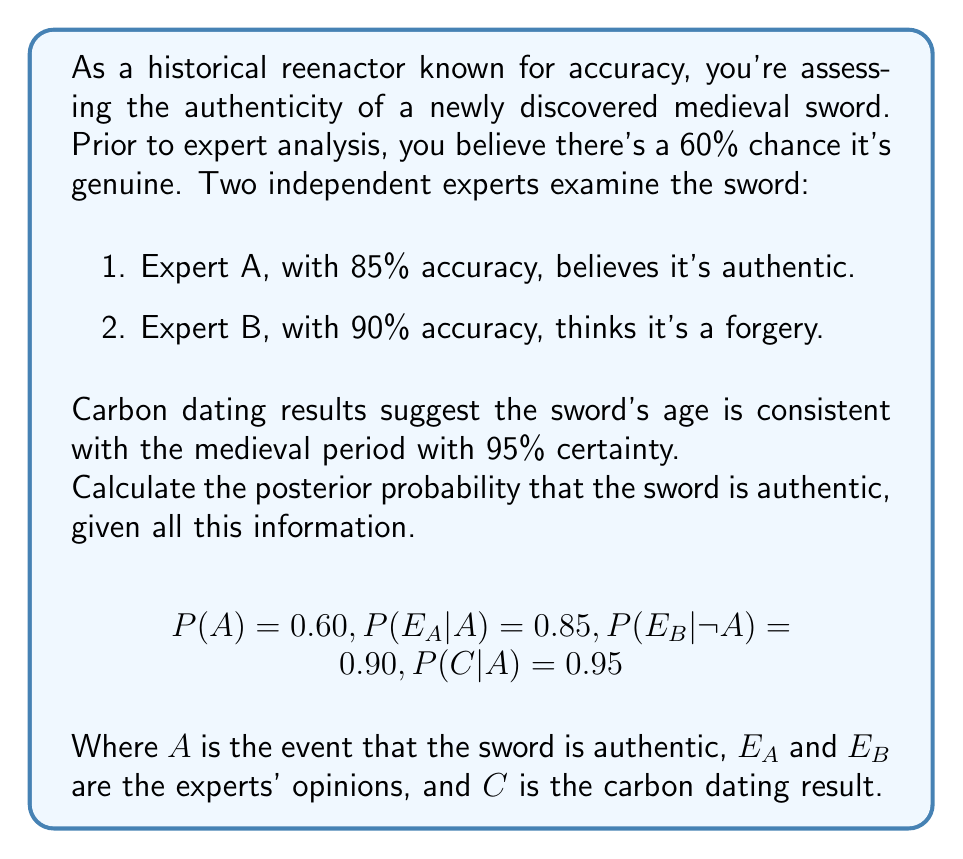Can you answer this question? Let's approach this step-by-step using Bayes' theorem:

1) First, we need to calculate the likelihood of observing all the evidence given the sword is authentic and not authentic:

   $$P(E_A, E_B, C|A) = P(E_A|A) \cdot P(E_B|A) \cdot P(C|A)$$
   $$P(E_A, E_B, C|\neg A) = P(E_A|\neg A) \cdot P(E_B|\neg A) \cdot P(C|\neg A)$$

2) We're given $P(E_A|A) = 0.85$, $P(C|A) = 0.95$, and $P(E_B|\neg A) = 0.90$. We need to calculate:

   $P(E_B|A) = 1 - P(E_B|\neg A) = 0.10$
   $P(E_A|\neg A) = 1 - P(E_A|A) = 0.15$
   $P(C|\neg A) = 1 - P(C|A) = 0.05$

3) Now we can calculate:

   $$P(E_A, E_B, C|A) = 0.85 \cdot 0.10 \cdot 0.95 = 0.08075$$
   $$P(E_A, E_B, C|\neg A) = 0.15 \cdot 0.90 \cdot 0.05 = 0.00675$$

4) Using Bayes' theorem:

   $$P(A|E_A, E_B, C) = \frac{P(A) \cdot P(E_A, E_B, C|A)}{P(A) \cdot P(E_A, E_B, C|A) + P(\neg A) \cdot P(E_A, E_B, C|\neg A)}$$

5) Substituting the values:

   $$P(A|E_A, E_B, C) = \frac{0.60 \cdot 0.08075}{0.60 \cdot 0.08075 + 0.40 \cdot 0.00675}$$

6) Calculating:

   $$P(A|E_A, E_B, C) = \frac{0.04845}{0.04845 + 0.00270} = \frac{0.04845}{0.05115} \approx 0.9472$$
Answer: 0.9472 or 94.72% 